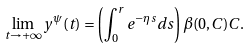<formula> <loc_0><loc_0><loc_500><loc_500>\lim _ { t \to + \infty } y ^ { \psi } ( t ) = \left ( \int _ { 0 } ^ { r } e ^ { - \eta s } d s \right ) \beta ( 0 , C ) C .</formula> 